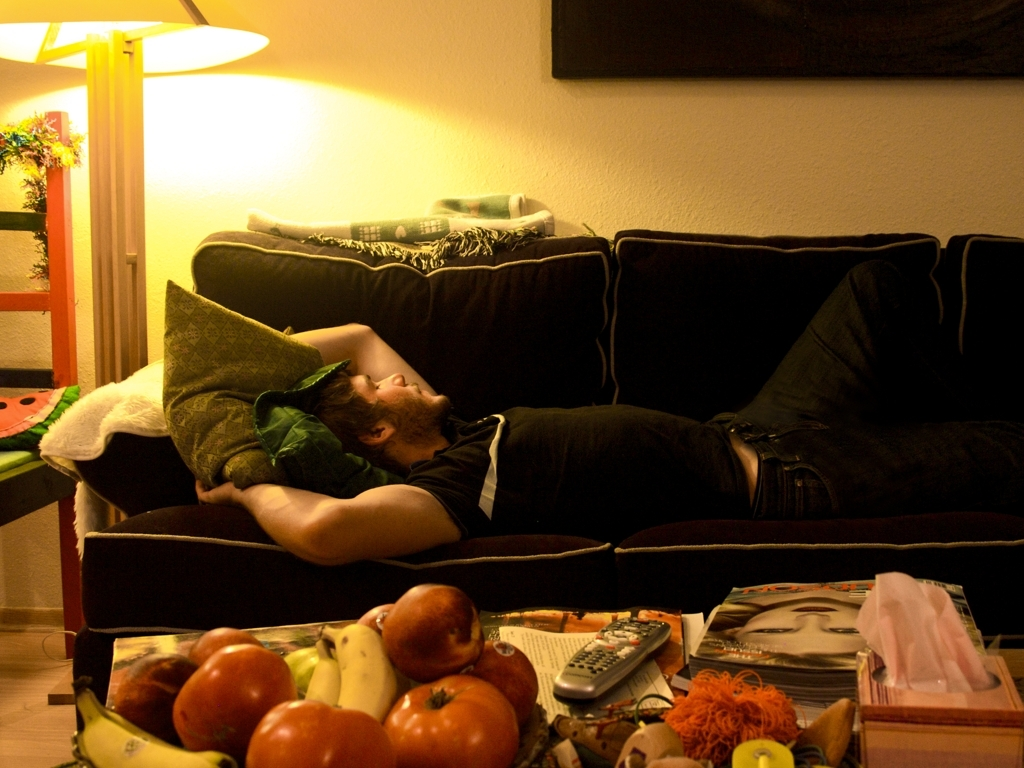Are the objects on the desktop sharply defined? Yes, the items placed on the table such as the fruit basket, remote controls, and magazines appear to have sharp and clear outlines, indicating that they are indeed sharply defined. 